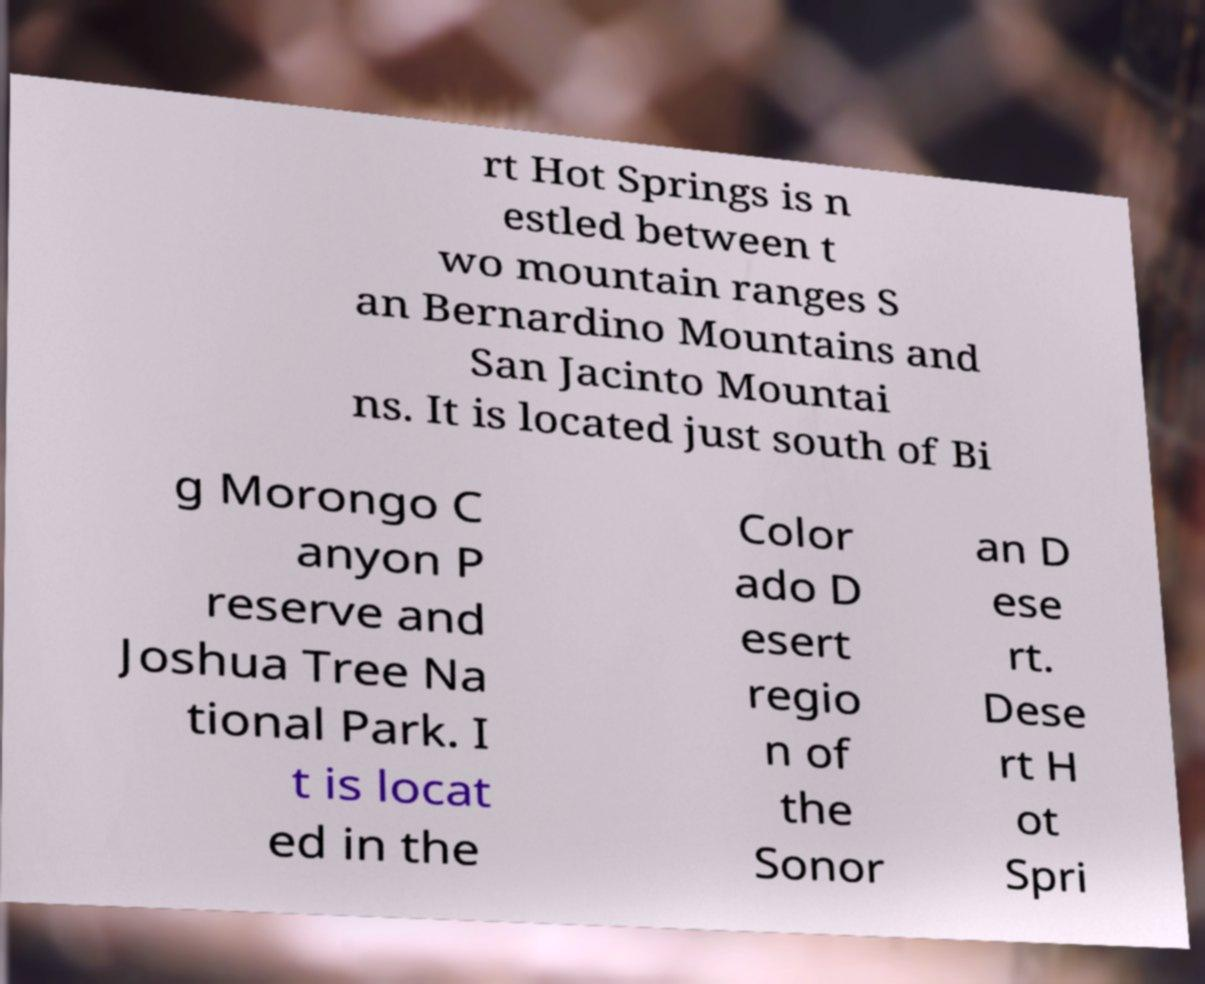What messages or text are displayed in this image? I need them in a readable, typed format. rt Hot Springs is n estled between t wo mountain ranges S an Bernardino Mountains and San Jacinto Mountai ns. It is located just south of Bi g Morongo C anyon P reserve and Joshua Tree Na tional Park. I t is locat ed in the Color ado D esert regio n of the Sonor an D ese rt. Dese rt H ot Spri 